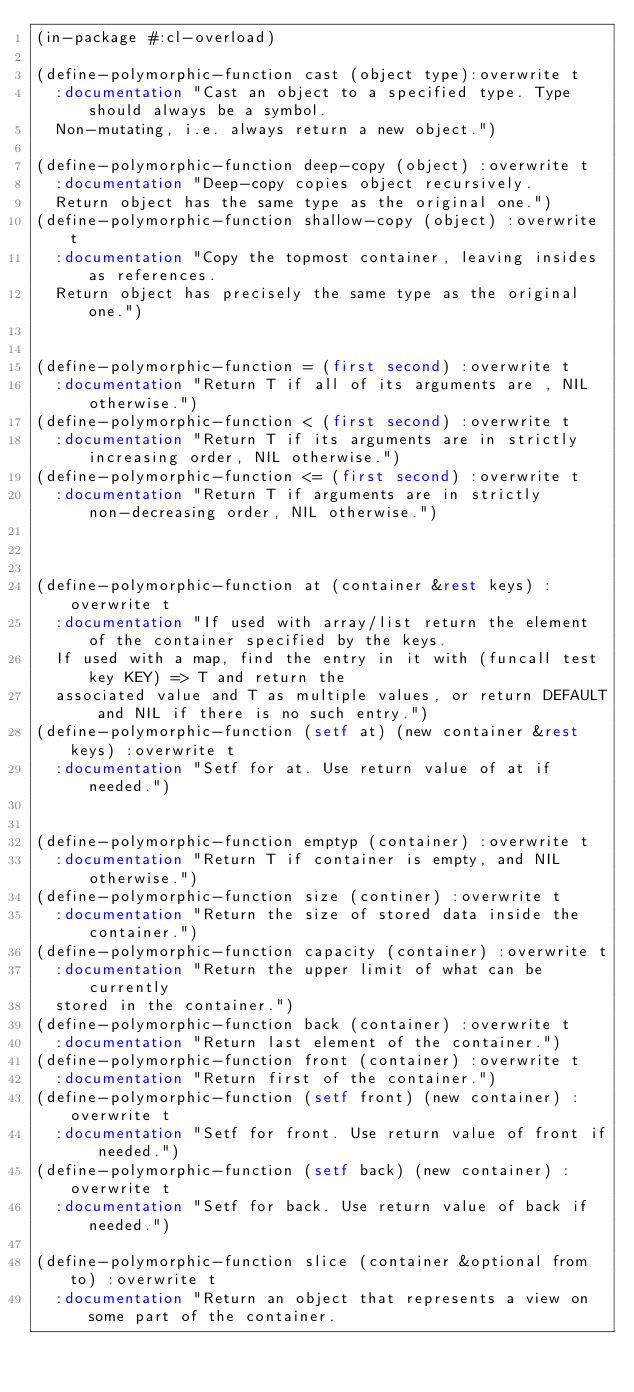<code> <loc_0><loc_0><loc_500><loc_500><_Lisp_>(in-package #:cl-overload)

(define-polymorphic-function cast (object type):overwrite t
  :documentation "Cast an object to a specified type. Type should always be a symbol.
  Non-mutating, i.e. always return a new object.")

(define-polymorphic-function deep-copy (object) :overwrite t
  :documentation "Deep-copy copies object recursively.
  Return object has the same type as the original one.")
(define-polymorphic-function shallow-copy (object) :overwrite t
  :documentation "Copy the topmost container, leaving insides as references.
  Return object has precisely the same type as the original one.")


(define-polymorphic-function = (first second) :overwrite t
  :documentation "Return T if all of its arguments are , NIL otherwise.")
(define-polymorphic-function < (first second) :overwrite t
  :documentation "Return T if its arguments are in strictly increasing order, NIL otherwise.")
(define-polymorphic-function <= (first second) :overwrite t
  :documentation "Return T if arguments are in strictly non-decreasing order, NIL otherwise.")



(define-polymorphic-function at (container &rest keys) :overwrite t
  :documentation "If used with array/list return the element of the container specified by the keys.
  If used with a map, find the entry in it with (funcall test key KEY) => T and return the
  associated value and T as multiple values, or return DEFAULT and NIL if there is no such entry.")
(define-polymorphic-function (setf at) (new container &rest keys) :overwrite t
  :documentation "Setf for at. Use return value of at if needed.")


(define-polymorphic-function emptyp (container) :overwrite t
  :documentation "Return T if container is empty, and NIL otherwise.")
(define-polymorphic-function size (continer) :overwrite t
  :documentation "Return the size of stored data inside the container.")
(define-polymorphic-function capacity (container) :overwrite t
  :documentation "Return the upper limit of what can be currently
  stored in the container.")
(define-polymorphic-function back (container) :overwrite t
  :documentation "Return last element of the container.")
(define-polymorphic-function front (container) :overwrite t
  :documentation "Return first of the container.")
(define-polymorphic-function (setf front) (new container) :overwrite t
  :documentation "Setf for front. Use return value of front if needed.")
(define-polymorphic-function (setf back) (new container) :overwrite t
  :documentation "Setf for back. Use return value of back if needed.")

(define-polymorphic-function slice (container &optional from to) :overwrite t
  :documentation "Return an object that represents a view on some part of the container.</code> 